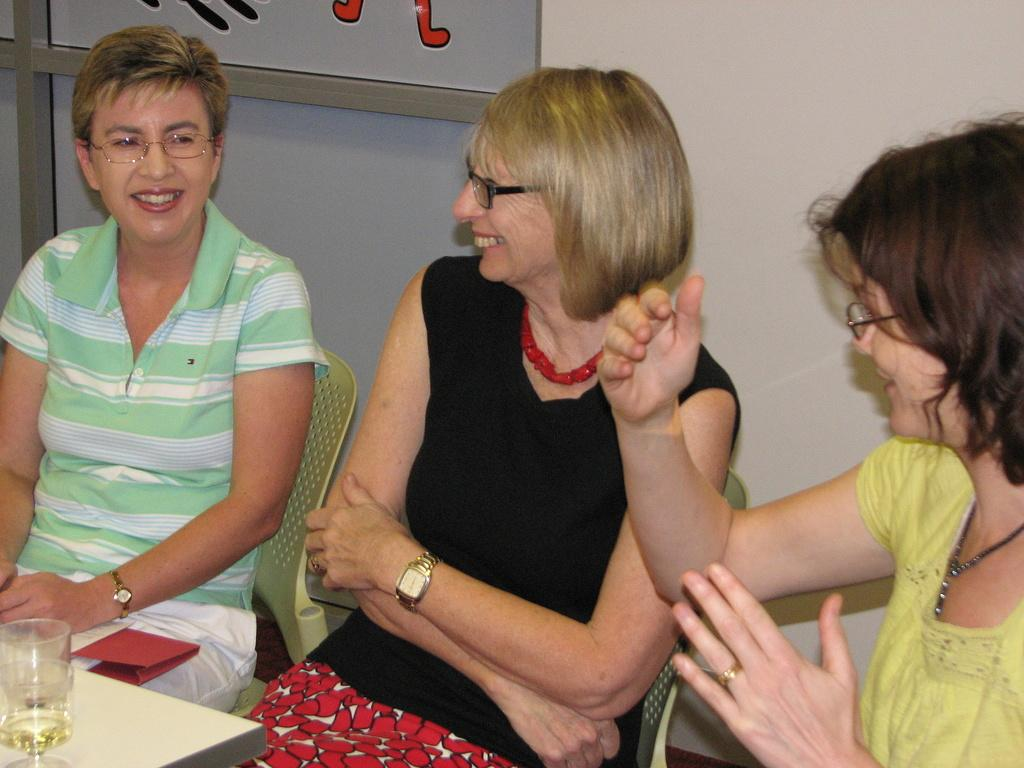What are the people in the image doing? The people in the image are sitting and smiling. What is located at the bottom of the image? There is a table at the bottom of the image. What object is placed on the table? A glass is placed on the table. What can be seen in the background of the image? There is a wall and a board in the background of the image. What type of haircut can be seen on the board in the background? There is no haircut or board with a haircut visible in the image. What is the people in the image using to engage in a battle? There is no battle or any indication of a battle in the image. 